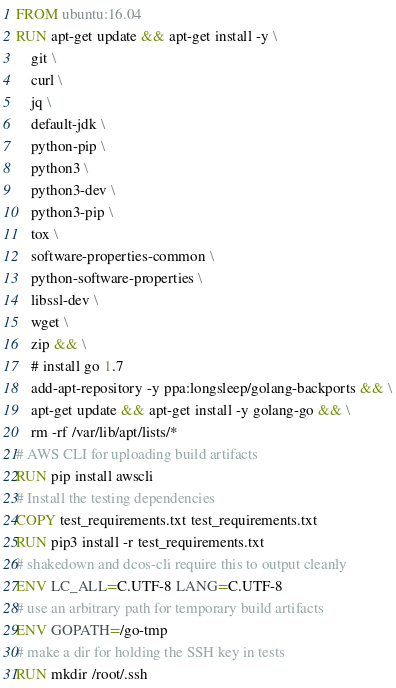<code> <loc_0><loc_0><loc_500><loc_500><_Dockerfile_>FROM ubuntu:16.04
RUN apt-get update && apt-get install -y \
    git \
    curl \
    jq \
    default-jdk \
    python-pip \
    python3 \
    python3-dev \
    python3-pip \
    tox \
    software-properties-common \
    python-software-properties \
    libssl-dev \
    wget \
    zip && \
    # install go 1.7
    add-apt-repository -y ppa:longsleep/golang-backports && \
    apt-get update && apt-get install -y golang-go && \
    rm -rf /var/lib/apt/lists/*
# AWS CLI for uploading build artifacts
RUN pip install awscli
# Install the testing dependencies
COPY test_requirements.txt test_requirements.txt
RUN pip3 install -r test_requirements.txt
# shakedown and dcos-cli require this to output cleanly
ENV LC_ALL=C.UTF-8 LANG=C.UTF-8
# use an arbitrary path for temporary build artifacts
ENV GOPATH=/go-tmp
# make a dir for holding the SSH key in tests
RUN mkdir /root/.ssh
</code> 